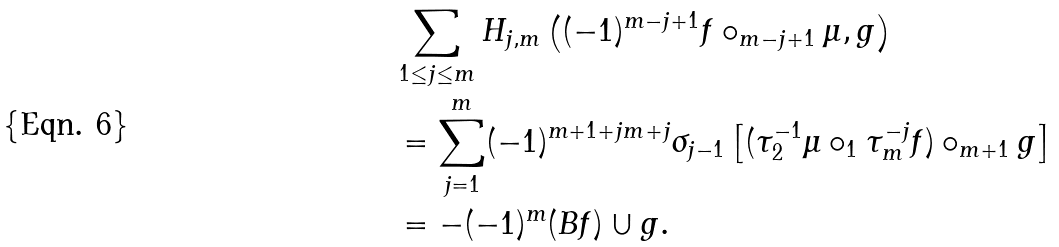Convert formula to latex. <formula><loc_0><loc_0><loc_500><loc_500>& \sum _ { 1 \leq j \leq m } H _ { j , m } \left ( ( - 1 ) ^ { m - j + 1 } f \circ _ { m - j + 1 } \mu , g \right ) \\ & = \sum _ { j = 1 } ^ { m } ( - 1 ) ^ { m + 1 + j m + j } \sigma _ { j - 1 } \left [ ( \tau _ { 2 } ^ { - 1 } \mu \circ _ { 1 } \tau _ { m } ^ { - j } f ) \circ _ { m + 1 } g \right ] \\ & = - ( - 1 ) ^ { m } ( B f ) \cup g .</formula> 